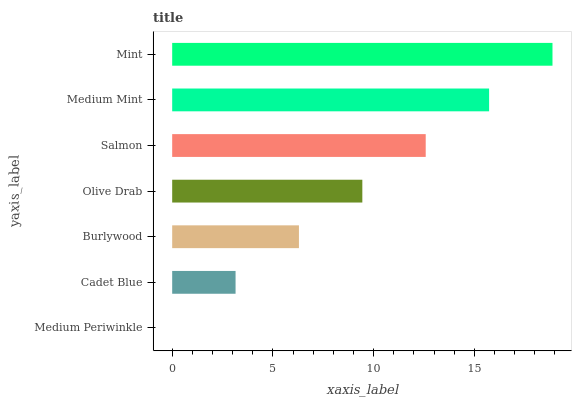Is Medium Periwinkle the minimum?
Answer yes or no. Yes. Is Mint the maximum?
Answer yes or no. Yes. Is Cadet Blue the minimum?
Answer yes or no. No. Is Cadet Blue the maximum?
Answer yes or no. No. Is Cadet Blue greater than Medium Periwinkle?
Answer yes or no. Yes. Is Medium Periwinkle less than Cadet Blue?
Answer yes or no. Yes. Is Medium Periwinkle greater than Cadet Blue?
Answer yes or no. No. Is Cadet Blue less than Medium Periwinkle?
Answer yes or no. No. Is Olive Drab the high median?
Answer yes or no. Yes. Is Olive Drab the low median?
Answer yes or no. Yes. Is Salmon the high median?
Answer yes or no. No. Is Mint the low median?
Answer yes or no. No. 